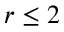<formula> <loc_0><loc_0><loc_500><loc_500>r \leq 2</formula> 